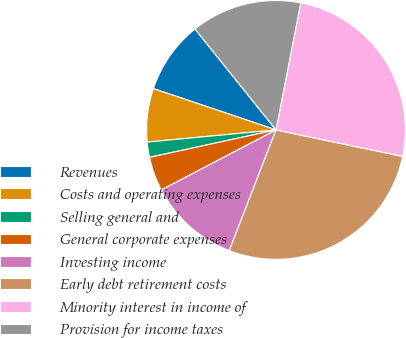<chart> <loc_0><loc_0><loc_500><loc_500><pie_chart><fcel>Revenues<fcel>Costs and operating expenses<fcel>Selling general and<fcel>General corporate expenses<fcel>Investing income<fcel>Early debt retirement costs<fcel>Minority interest in income of<fcel>Provision for income taxes<nl><fcel>9.06%<fcel>6.67%<fcel>1.9%<fcel>4.28%<fcel>11.44%<fcel>27.6%<fcel>25.22%<fcel>13.83%<nl></chart> 